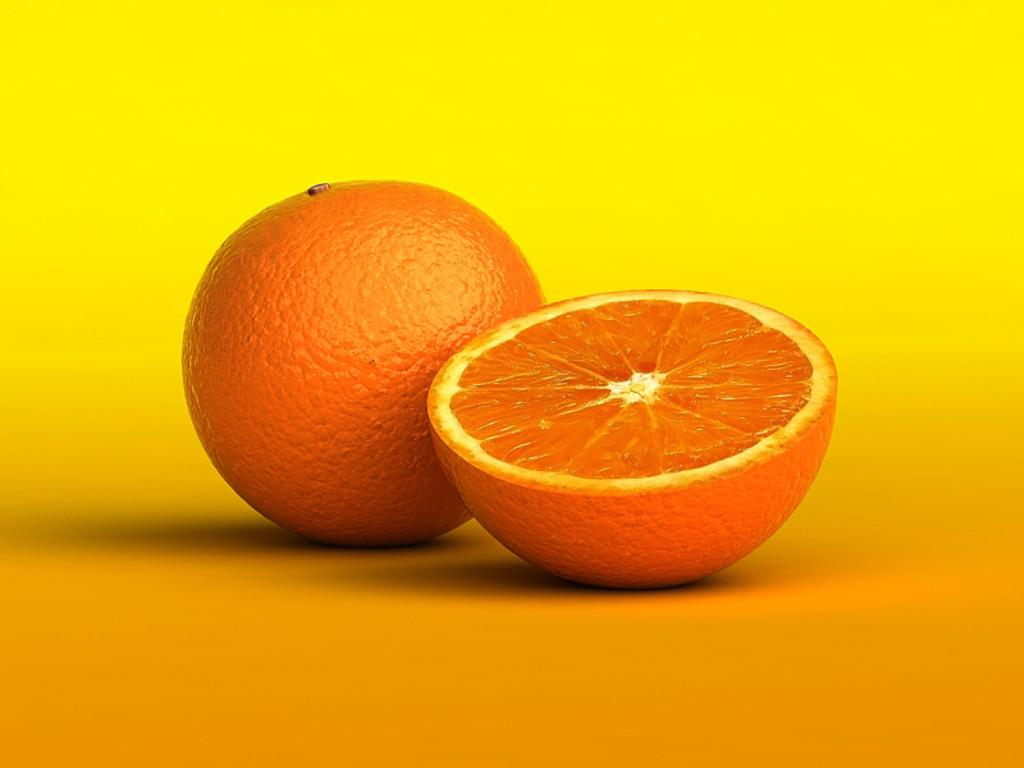What type of fruit is the main subject of the image? There is an orange in the image. Can you describe the orange in more detail? There is a slice of an orange in the image. What color is the surface the orange is placed on? The surface the orange is on is orange in color. What color is the background of the image? The background of the image is yellow. How many legs can be seen on the orange in the image? Oranges do not have legs, so none can be seen in the image. 